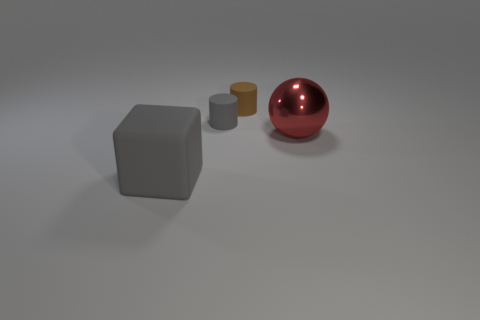What can you infer about the size of the objects relative to each other? The cube is the largest object, with its sides likely being at least twice the diameter of the small gray cylinder. The brown cylinder is intermediate in size, bigger than the small gray cylinder but smaller than the cube. The large red sphere is comparable to the cube in size and volumetric presence in the space. Could the gray cylinder fit inside the red sphere? If the red sphere were hollow, its size suggests it could encompass the gray cylinder. The sphere's diameter appears to be several times larger than the cylinder's height and diameter, allowing for the cylinder to potentially fit within its volume. 